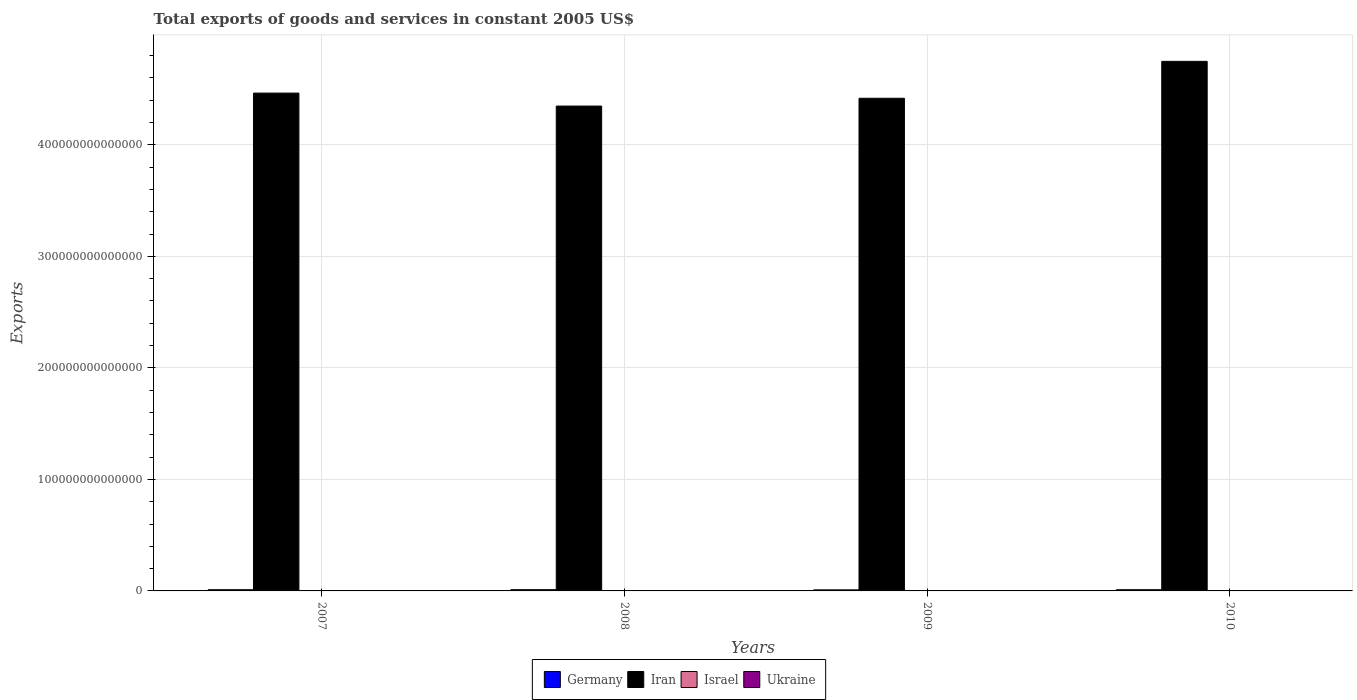How many groups of bars are there?
Provide a succinct answer. 4. How many bars are there on the 4th tick from the right?
Offer a terse response. 4. What is the label of the 1st group of bars from the left?
Keep it short and to the point. 2007. In how many cases, is the number of bars for a given year not equal to the number of legend labels?
Offer a very short reply. 0. What is the total exports of goods and services in Israel in 2008?
Provide a short and direct response. 3.03e+11. Across all years, what is the maximum total exports of goods and services in Ukraine?
Your response must be concise. 1.71e+11. Across all years, what is the minimum total exports of goods and services in Iran?
Your answer should be very brief. 4.35e+14. In which year was the total exports of goods and services in Ukraine maximum?
Keep it short and to the point. 2008. What is the total total exports of goods and services in Ukraine in the graph?
Provide a succinct answer. 6.06e+11. What is the difference between the total exports of goods and services in Israel in 2007 and that in 2008?
Your answer should be very brief. -1.65e+1. What is the difference between the total exports of goods and services in Israel in 2010 and the total exports of goods and services in Iran in 2009?
Provide a succinct answer. -4.41e+14. What is the average total exports of goods and services in Israel per year?
Keep it short and to the point. 2.91e+11. In the year 2007, what is the difference between the total exports of goods and services in Ukraine and total exports of goods and services in Israel?
Provide a succinct answer. -1.24e+11. In how many years, is the total exports of goods and services in Iran greater than 360000000000000 US$?
Your answer should be compact. 4. What is the ratio of the total exports of goods and services in Iran in 2009 to that in 2010?
Your answer should be very brief. 0.93. Is the total exports of goods and services in Ukraine in 2007 less than that in 2009?
Your response must be concise. No. What is the difference between the highest and the second highest total exports of goods and services in Ukraine?
Your answer should be very brief. 9.23e+09. What is the difference between the highest and the lowest total exports of goods and services in Iran?
Offer a very short reply. 4.01e+13. Is the sum of the total exports of goods and services in Israel in 2008 and 2010 greater than the maximum total exports of goods and services in Ukraine across all years?
Give a very brief answer. Yes. Is it the case that in every year, the sum of the total exports of goods and services in Israel and total exports of goods and services in Iran is greater than the sum of total exports of goods and services in Germany and total exports of goods and services in Ukraine?
Provide a succinct answer. Yes. What does the 1st bar from the left in 2010 represents?
Ensure brevity in your answer.  Germany. How many bars are there?
Ensure brevity in your answer.  16. Are all the bars in the graph horizontal?
Your answer should be compact. No. How many years are there in the graph?
Offer a very short reply. 4. What is the difference between two consecutive major ticks on the Y-axis?
Offer a very short reply. 1.00e+14. Where does the legend appear in the graph?
Offer a very short reply. Bottom center. What is the title of the graph?
Offer a terse response. Total exports of goods and services in constant 2005 US$. What is the label or title of the X-axis?
Provide a short and direct response. Years. What is the label or title of the Y-axis?
Make the answer very short. Exports. What is the Exports of Germany in 2007?
Offer a terse response. 1.09e+12. What is the Exports of Iran in 2007?
Give a very brief answer. 4.46e+14. What is the Exports of Israel in 2007?
Make the answer very short. 2.86e+11. What is the Exports of Ukraine in 2007?
Offer a terse response. 1.62e+11. What is the Exports of Germany in 2008?
Provide a succinct answer. 1.11e+12. What is the Exports in Iran in 2008?
Offer a terse response. 4.35e+14. What is the Exports in Israel in 2008?
Keep it short and to the point. 3.03e+11. What is the Exports in Ukraine in 2008?
Keep it short and to the point. 1.71e+11. What is the Exports in Germany in 2009?
Provide a short and direct response. 9.52e+11. What is the Exports of Iran in 2009?
Make the answer very short. 4.42e+14. What is the Exports in Israel in 2009?
Ensure brevity in your answer.  2.67e+11. What is the Exports of Ukraine in 2009?
Make the answer very short. 1.34e+11. What is the Exports of Germany in 2010?
Ensure brevity in your answer.  1.09e+12. What is the Exports of Iran in 2010?
Keep it short and to the point. 4.75e+14. What is the Exports in Israel in 2010?
Your answer should be compact. 3.07e+11. What is the Exports of Ukraine in 2010?
Provide a short and direct response. 1.40e+11. Across all years, what is the maximum Exports of Germany?
Ensure brevity in your answer.  1.11e+12. Across all years, what is the maximum Exports of Iran?
Provide a succinct answer. 4.75e+14. Across all years, what is the maximum Exports in Israel?
Provide a short and direct response. 3.07e+11. Across all years, what is the maximum Exports of Ukraine?
Keep it short and to the point. 1.71e+11. Across all years, what is the minimum Exports of Germany?
Your response must be concise. 9.52e+11. Across all years, what is the minimum Exports of Iran?
Ensure brevity in your answer.  4.35e+14. Across all years, what is the minimum Exports of Israel?
Offer a terse response. 2.67e+11. Across all years, what is the minimum Exports of Ukraine?
Provide a short and direct response. 1.34e+11. What is the total Exports in Germany in the graph?
Your answer should be compact. 4.24e+12. What is the total Exports in Iran in the graph?
Offer a very short reply. 1.80e+15. What is the total Exports in Israel in the graph?
Your response must be concise. 1.16e+12. What is the total Exports in Ukraine in the graph?
Offer a terse response. 6.06e+11. What is the difference between the Exports of Germany in 2007 and that in 2008?
Your answer should be very brief. -2.10e+1. What is the difference between the Exports in Iran in 2007 and that in 2008?
Provide a succinct answer. 1.16e+13. What is the difference between the Exports in Israel in 2007 and that in 2008?
Provide a succinct answer. -1.65e+1. What is the difference between the Exports in Ukraine in 2007 and that in 2008?
Offer a terse response. -9.23e+09. What is the difference between the Exports in Germany in 2007 and that in 2009?
Make the answer very short. 1.37e+11. What is the difference between the Exports in Iran in 2007 and that in 2009?
Provide a succinct answer. 4.64e+12. What is the difference between the Exports in Israel in 2007 and that in 2009?
Make the answer very short. 1.95e+1. What is the difference between the Exports of Ukraine in 2007 and that in 2009?
Make the answer very short. 2.84e+1. What is the difference between the Exports in Germany in 2007 and that in 2010?
Give a very brief answer. -9.81e+08. What is the difference between the Exports of Iran in 2007 and that in 2010?
Keep it short and to the point. -2.85e+13. What is the difference between the Exports in Israel in 2007 and that in 2010?
Offer a terse response. -2.06e+1. What is the difference between the Exports in Ukraine in 2007 and that in 2010?
Your answer should be very brief. 2.24e+1. What is the difference between the Exports in Germany in 2008 and that in 2009?
Make the answer very short. 1.58e+11. What is the difference between the Exports of Iran in 2008 and that in 2009?
Your answer should be very brief. -6.98e+12. What is the difference between the Exports in Israel in 2008 and that in 2009?
Give a very brief answer. 3.60e+1. What is the difference between the Exports in Ukraine in 2008 and that in 2009?
Ensure brevity in your answer.  3.77e+1. What is the difference between the Exports in Germany in 2008 and that in 2010?
Provide a short and direct response. 2.01e+1. What is the difference between the Exports of Iran in 2008 and that in 2010?
Make the answer very short. -4.01e+13. What is the difference between the Exports of Israel in 2008 and that in 2010?
Your answer should be compact. -4.03e+09. What is the difference between the Exports of Ukraine in 2008 and that in 2010?
Ensure brevity in your answer.  3.17e+1. What is the difference between the Exports of Germany in 2009 and that in 2010?
Provide a succinct answer. -1.38e+11. What is the difference between the Exports in Iran in 2009 and that in 2010?
Provide a short and direct response. -3.31e+13. What is the difference between the Exports of Israel in 2009 and that in 2010?
Your answer should be compact. -4.00e+1. What is the difference between the Exports in Ukraine in 2009 and that in 2010?
Provide a succinct answer. -6.01e+09. What is the difference between the Exports in Germany in 2007 and the Exports in Iran in 2008?
Offer a very short reply. -4.34e+14. What is the difference between the Exports of Germany in 2007 and the Exports of Israel in 2008?
Offer a very short reply. 7.86e+11. What is the difference between the Exports of Germany in 2007 and the Exports of Ukraine in 2008?
Give a very brief answer. 9.18e+11. What is the difference between the Exports in Iran in 2007 and the Exports in Israel in 2008?
Give a very brief answer. 4.46e+14. What is the difference between the Exports in Iran in 2007 and the Exports in Ukraine in 2008?
Offer a very short reply. 4.46e+14. What is the difference between the Exports in Israel in 2007 and the Exports in Ukraine in 2008?
Provide a short and direct response. 1.15e+11. What is the difference between the Exports of Germany in 2007 and the Exports of Iran in 2009?
Make the answer very short. -4.41e+14. What is the difference between the Exports in Germany in 2007 and the Exports in Israel in 2009?
Your answer should be very brief. 8.22e+11. What is the difference between the Exports of Germany in 2007 and the Exports of Ukraine in 2009?
Give a very brief answer. 9.56e+11. What is the difference between the Exports in Iran in 2007 and the Exports in Israel in 2009?
Offer a terse response. 4.46e+14. What is the difference between the Exports in Iran in 2007 and the Exports in Ukraine in 2009?
Keep it short and to the point. 4.46e+14. What is the difference between the Exports in Israel in 2007 and the Exports in Ukraine in 2009?
Make the answer very short. 1.53e+11. What is the difference between the Exports in Germany in 2007 and the Exports in Iran in 2010?
Give a very brief answer. -4.74e+14. What is the difference between the Exports in Germany in 2007 and the Exports in Israel in 2010?
Your response must be concise. 7.82e+11. What is the difference between the Exports of Germany in 2007 and the Exports of Ukraine in 2010?
Make the answer very short. 9.50e+11. What is the difference between the Exports in Iran in 2007 and the Exports in Israel in 2010?
Provide a short and direct response. 4.46e+14. What is the difference between the Exports in Iran in 2007 and the Exports in Ukraine in 2010?
Give a very brief answer. 4.46e+14. What is the difference between the Exports in Israel in 2007 and the Exports in Ukraine in 2010?
Provide a succinct answer. 1.47e+11. What is the difference between the Exports of Germany in 2008 and the Exports of Iran in 2009?
Your answer should be very brief. -4.41e+14. What is the difference between the Exports of Germany in 2008 and the Exports of Israel in 2009?
Make the answer very short. 8.43e+11. What is the difference between the Exports of Germany in 2008 and the Exports of Ukraine in 2009?
Ensure brevity in your answer.  9.77e+11. What is the difference between the Exports in Iran in 2008 and the Exports in Israel in 2009?
Give a very brief answer. 4.35e+14. What is the difference between the Exports of Iran in 2008 and the Exports of Ukraine in 2009?
Provide a succinct answer. 4.35e+14. What is the difference between the Exports in Israel in 2008 and the Exports in Ukraine in 2009?
Ensure brevity in your answer.  1.69e+11. What is the difference between the Exports in Germany in 2008 and the Exports in Iran in 2010?
Make the answer very short. -4.74e+14. What is the difference between the Exports of Germany in 2008 and the Exports of Israel in 2010?
Provide a succinct answer. 8.03e+11. What is the difference between the Exports of Germany in 2008 and the Exports of Ukraine in 2010?
Offer a terse response. 9.71e+11. What is the difference between the Exports of Iran in 2008 and the Exports of Israel in 2010?
Your response must be concise. 4.34e+14. What is the difference between the Exports of Iran in 2008 and the Exports of Ukraine in 2010?
Offer a very short reply. 4.35e+14. What is the difference between the Exports of Israel in 2008 and the Exports of Ukraine in 2010?
Your answer should be very brief. 1.63e+11. What is the difference between the Exports in Germany in 2009 and the Exports in Iran in 2010?
Your response must be concise. -4.74e+14. What is the difference between the Exports in Germany in 2009 and the Exports in Israel in 2010?
Give a very brief answer. 6.45e+11. What is the difference between the Exports in Germany in 2009 and the Exports in Ukraine in 2010?
Ensure brevity in your answer.  8.12e+11. What is the difference between the Exports in Iran in 2009 and the Exports in Israel in 2010?
Your response must be concise. 4.41e+14. What is the difference between the Exports of Iran in 2009 and the Exports of Ukraine in 2010?
Give a very brief answer. 4.42e+14. What is the difference between the Exports in Israel in 2009 and the Exports in Ukraine in 2010?
Provide a succinct answer. 1.27e+11. What is the average Exports in Germany per year?
Provide a succinct answer. 1.06e+12. What is the average Exports in Iran per year?
Your answer should be very brief. 4.49e+14. What is the average Exports of Israel per year?
Ensure brevity in your answer.  2.91e+11. What is the average Exports of Ukraine per year?
Give a very brief answer. 1.52e+11. In the year 2007, what is the difference between the Exports in Germany and Exports in Iran?
Provide a short and direct response. -4.45e+14. In the year 2007, what is the difference between the Exports in Germany and Exports in Israel?
Give a very brief answer. 8.03e+11. In the year 2007, what is the difference between the Exports of Germany and Exports of Ukraine?
Give a very brief answer. 9.27e+11. In the year 2007, what is the difference between the Exports of Iran and Exports of Israel?
Your answer should be compact. 4.46e+14. In the year 2007, what is the difference between the Exports of Iran and Exports of Ukraine?
Your answer should be very brief. 4.46e+14. In the year 2007, what is the difference between the Exports of Israel and Exports of Ukraine?
Keep it short and to the point. 1.24e+11. In the year 2008, what is the difference between the Exports of Germany and Exports of Iran?
Provide a succinct answer. -4.34e+14. In the year 2008, what is the difference between the Exports of Germany and Exports of Israel?
Your answer should be very brief. 8.07e+11. In the year 2008, what is the difference between the Exports of Germany and Exports of Ukraine?
Provide a succinct answer. 9.39e+11. In the year 2008, what is the difference between the Exports of Iran and Exports of Israel?
Ensure brevity in your answer.  4.34e+14. In the year 2008, what is the difference between the Exports of Iran and Exports of Ukraine?
Provide a short and direct response. 4.35e+14. In the year 2008, what is the difference between the Exports in Israel and Exports in Ukraine?
Offer a terse response. 1.31e+11. In the year 2009, what is the difference between the Exports of Germany and Exports of Iran?
Ensure brevity in your answer.  -4.41e+14. In the year 2009, what is the difference between the Exports in Germany and Exports in Israel?
Your answer should be very brief. 6.85e+11. In the year 2009, what is the difference between the Exports of Germany and Exports of Ukraine?
Provide a succinct answer. 8.18e+11. In the year 2009, what is the difference between the Exports of Iran and Exports of Israel?
Offer a terse response. 4.41e+14. In the year 2009, what is the difference between the Exports in Iran and Exports in Ukraine?
Ensure brevity in your answer.  4.42e+14. In the year 2009, what is the difference between the Exports in Israel and Exports in Ukraine?
Keep it short and to the point. 1.33e+11. In the year 2010, what is the difference between the Exports of Germany and Exports of Iran?
Your answer should be compact. -4.74e+14. In the year 2010, what is the difference between the Exports of Germany and Exports of Israel?
Provide a short and direct response. 7.83e+11. In the year 2010, what is the difference between the Exports in Germany and Exports in Ukraine?
Your answer should be compact. 9.50e+11. In the year 2010, what is the difference between the Exports of Iran and Exports of Israel?
Provide a succinct answer. 4.75e+14. In the year 2010, what is the difference between the Exports in Iran and Exports in Ukraine?
Offer a terse response. 4.75e+14. In the year 2010, what is the difference between the Exports in Israel and Exports in Ukraine?
Keep it short and to the point. 1.67e+11. What is the ratio of the Exports in Iran in 2007 to that in 2008?
Offer a very short reply. 1.03. What is the ratio of the Exports of Israel in 2007 to that in 2008?
Your answer should be very brief. 0.95. What is the ratio of the Exports of Ukraine in 2007 to that in 2008?
Your answer should be very brief. 0.95. What is the ratio of the Exports in Germany in 2007 to that in 2009?
Your answer should be very brief. 1.14. What is the ratio of the Exports of Iran in 2007 to that in 2009?
Your answer should be very brief. 1.01. What is the ratio of the Exports of Israel in 2007 to that in 2009?
Offer a very short reply. 1.07. What is the ratio of the Exports of Ukraine in 2007 to that in 2009?
Offer a terse response. 1.21. What is the ratio of the Exports of Germany in 2007 to that in 2010?
Your answer should be compact. 1. What is the ratio of the Exports of Israel in 2007 to that in 2010?
Ensure brevity in your answer.  0.93. What is the ratio of the Exports of Ukraine in 2007 to that in 2010?
Keep it short and to the point. 1.16. What is the ratio of the Exports in Germany in 2008 to that in 2009?
Offer a very short reply. 1.17. What is the ratio of the Exports of Iran in 2008 to that in 2009?
Provide a succinct answer. 0.98. What is the ratio of the Exports of Israel in 2008 to that in 2009?
Your answer should be very brief. 1.14. What is the ratio of the Exports of Ukraine in 2008 to that in 2009?
Offer a terse response. 1.28. What is the ratio of the Exports in Germany in 2008 to that in 2010?
Provide a short and direct response. 1.02. What is the ratio of the Exports in Iran in 2008 to that in 2010?
Make the answer very short. 0.92. What is the ratio of the Exports in Israel in 2008 to that in 2010?
Provide a succinct answer. 0.99. What is the ratio of the Exports of Ukraine in 2008 to that in 2010?
Your response must be concise. 1.23. What is the ratio of the Exports in Germany in 2009 to that in 2010?
Provide a short and direct response. 0.87. What is the ratio of the Exports of Iran in 2009 to that in 2010?
Make the answer very short. 0.93. What is the ratio of the Exports of Israel in 2009 to that in 2010?
Give a very brief answer. 0.87. What is the ratio of the Exports in Ukraine in 2009 to that in 2010?
Provide a short and direct response. 0.96. What is the difference between the highest and the second highest Exports of Germany?
Provide a short and direct response. 2.01e+1. What is the difference between the highest and the second highest Exports of Iran?
Provide a short and direct response. 2.85e+13. What is the difference between the highest and the second highest Exports in Israel?
Make the answer very short. 4.03e+09. What is the difference between the highest and the second highest Exports in Ukraine?
Your answer should be very brief. 9.23e+09. What is the difference between the highest and the lowest Exports in Germany?
Ensure brevity in your answer.  1.58e+11. What is the difference between the highest and the lowest Exports of Iran?
Your answer should be compact. 4.01e+13. What is the difference between the highest and the lowest Exports of Israel?
Your response must be concise. 4.00e+1. What is the difference between the highest and the lowest Exports in Ukraine?
Keep it short and to the point. 3.77e+1. 